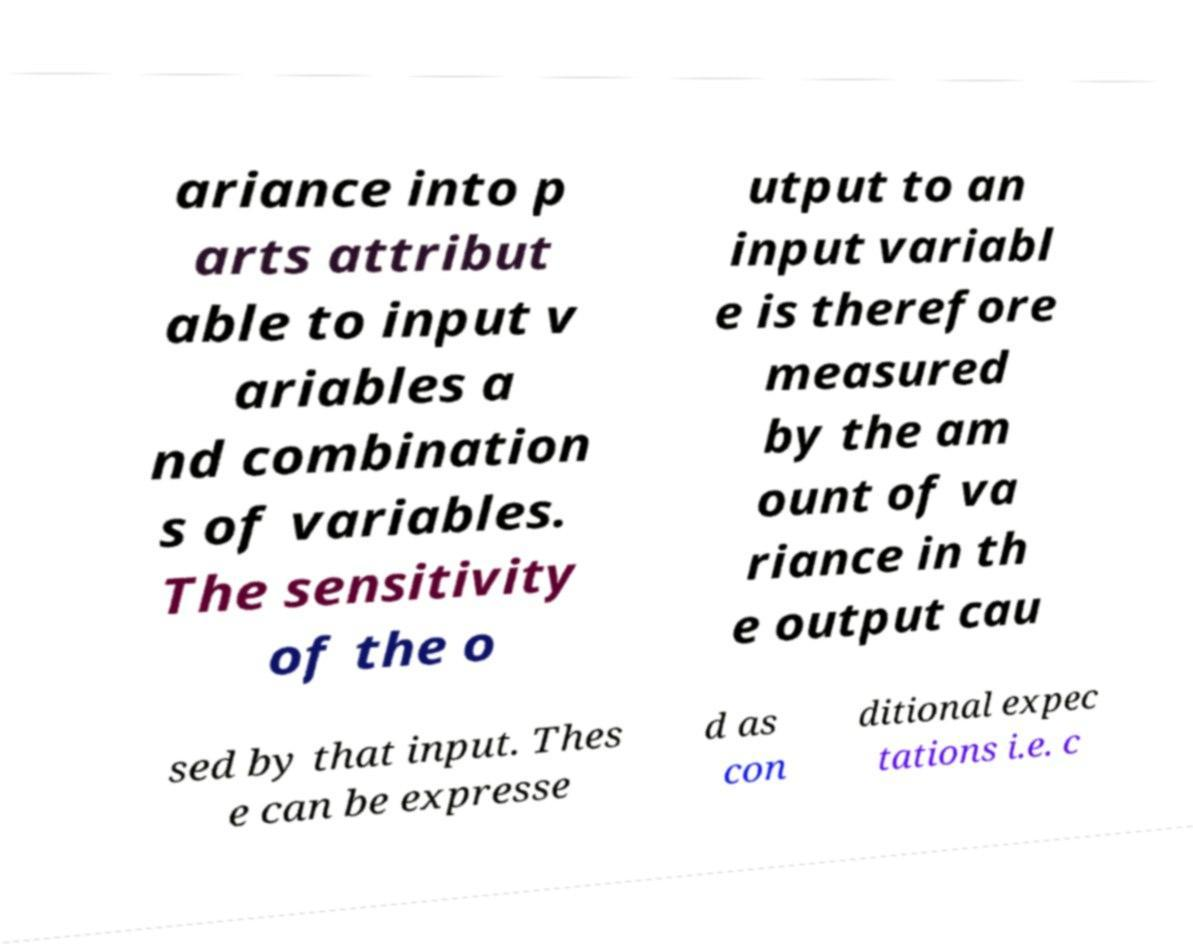What messages or text are displayed in this image? I need them in a readable, typed format. ariance into p arts attribut able to input v ariables a nd combination s of variables. The sensitivity of the o utput to an input variabl e is therefore measured by the am ount of va riance in th e output cau sed by that input. Thes e can be expresse d as con ditional expec tations i.e. c 